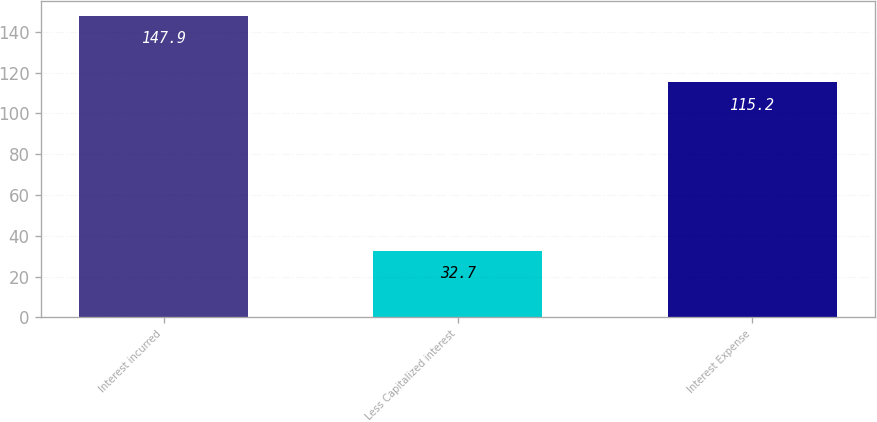<chart> <loc_0><loc_0><loc_500><loc_500><bar_chart><fcel>Interest incurred<fcel>Less Capitalized interest<fcel>Interest Expense<nl><fcel>147.9<fcel>32.7<fcel>115.2<nl></chart> 